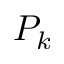<formula> <loc_0><loc_0><loc_500><loc_500>P _ { k }</formula> 